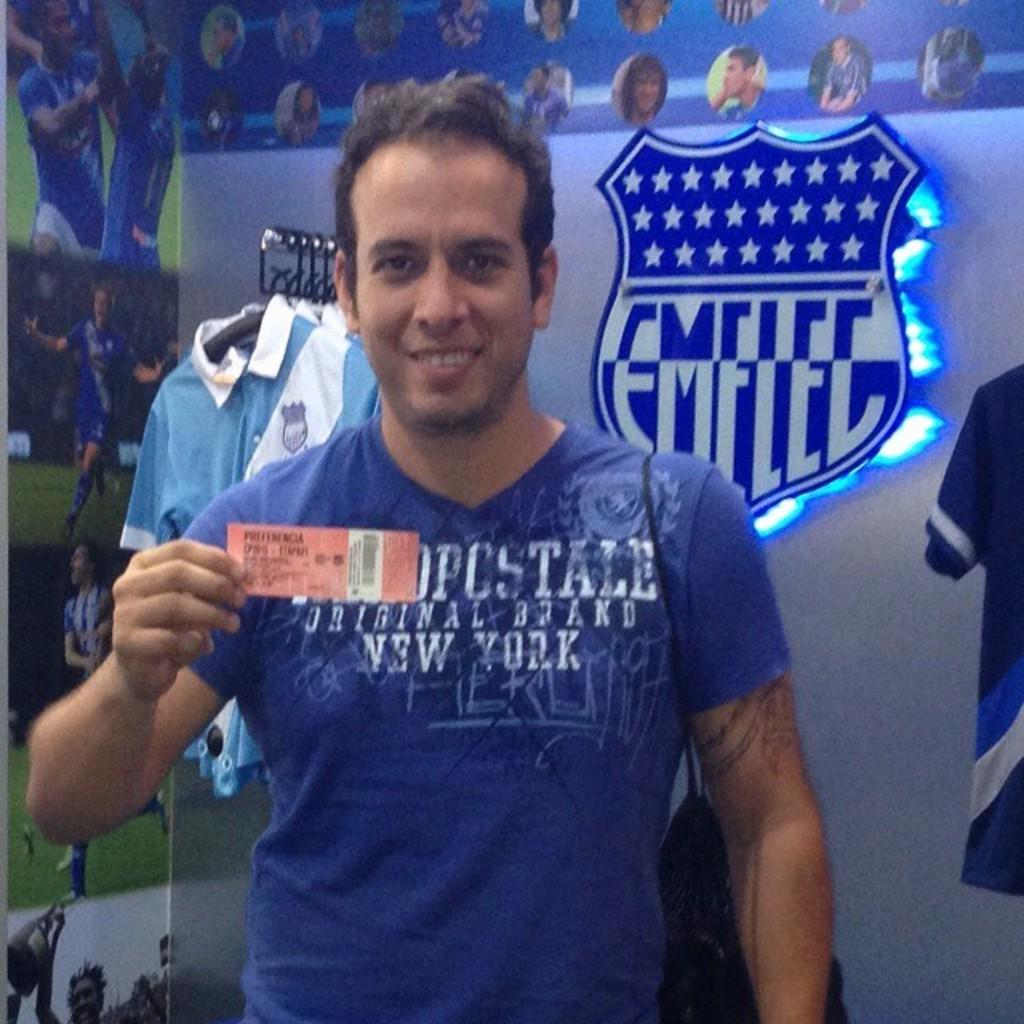<image>
Give a short and clear explanation of the subsequent image. A man wearing a t-shirt with new york on it poses with a ticket for a game. 